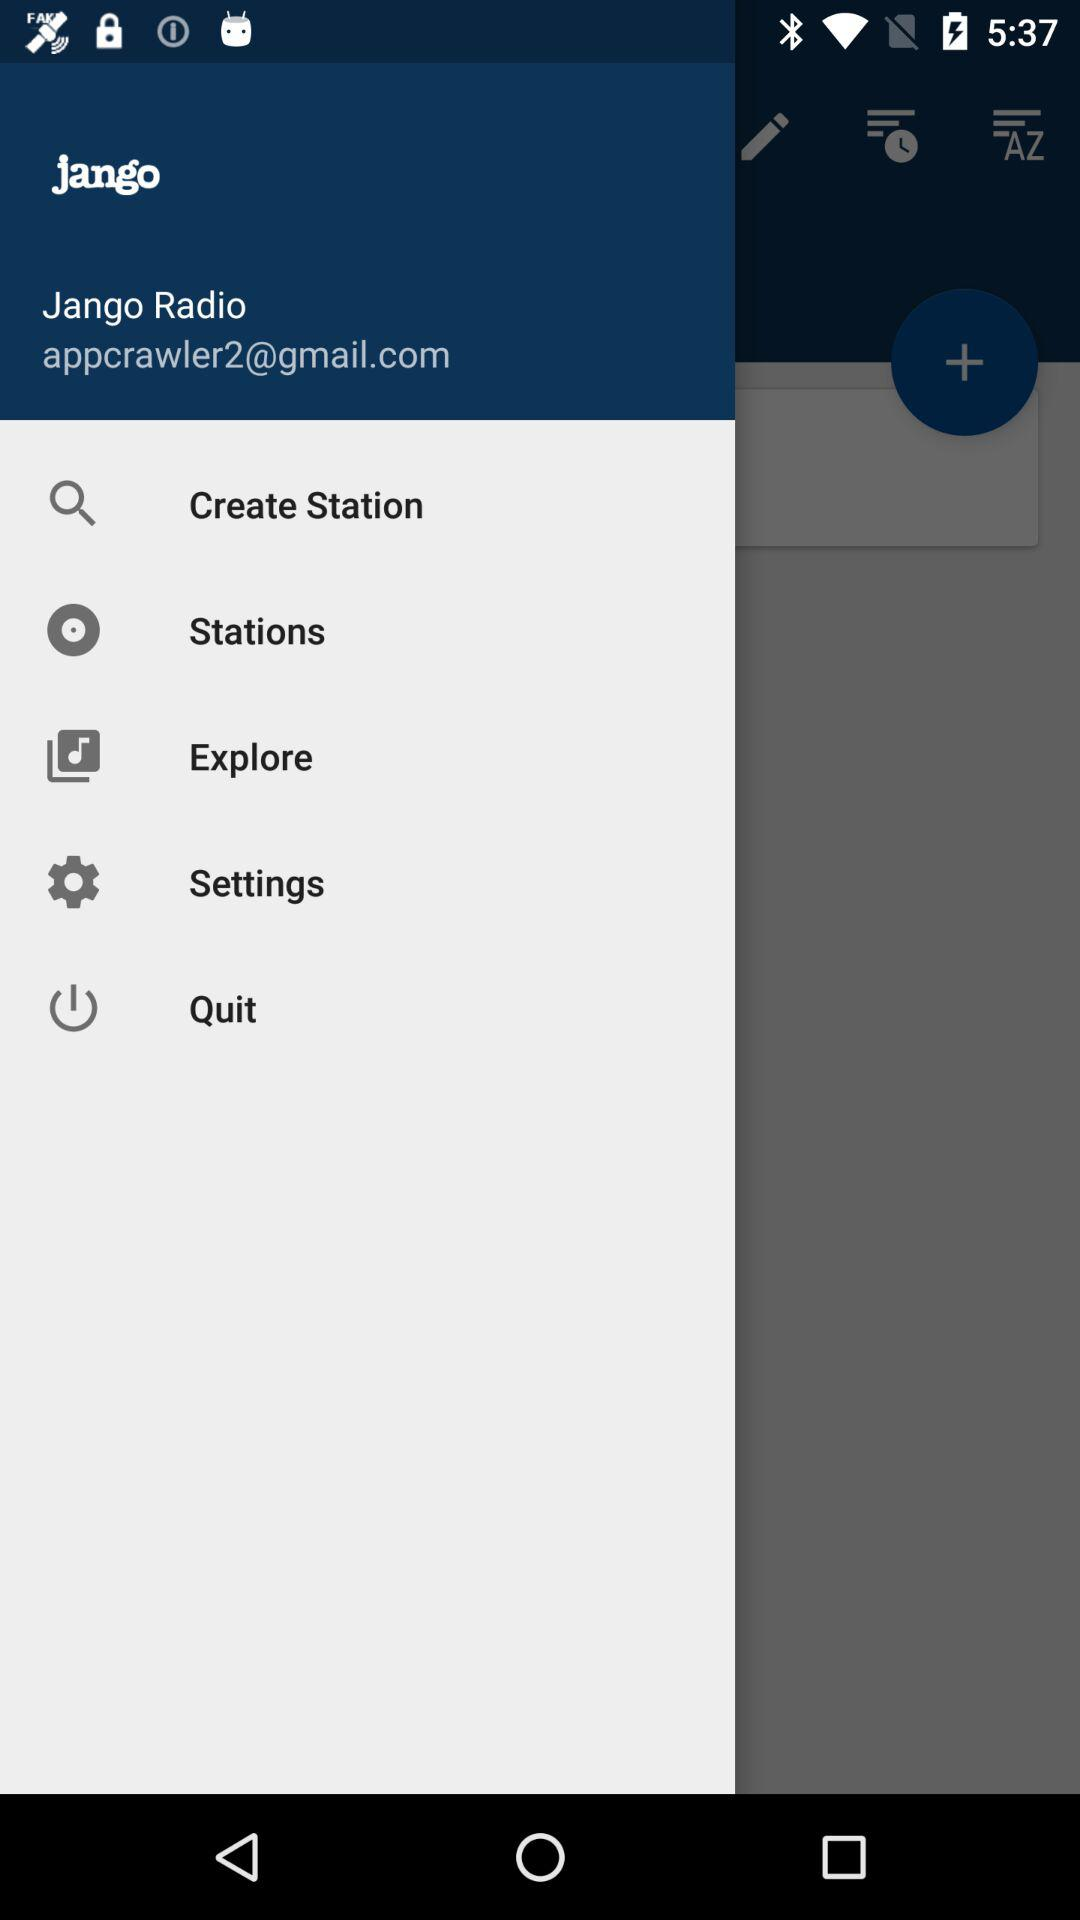What is the application name? The application name is "Jango Radio". 